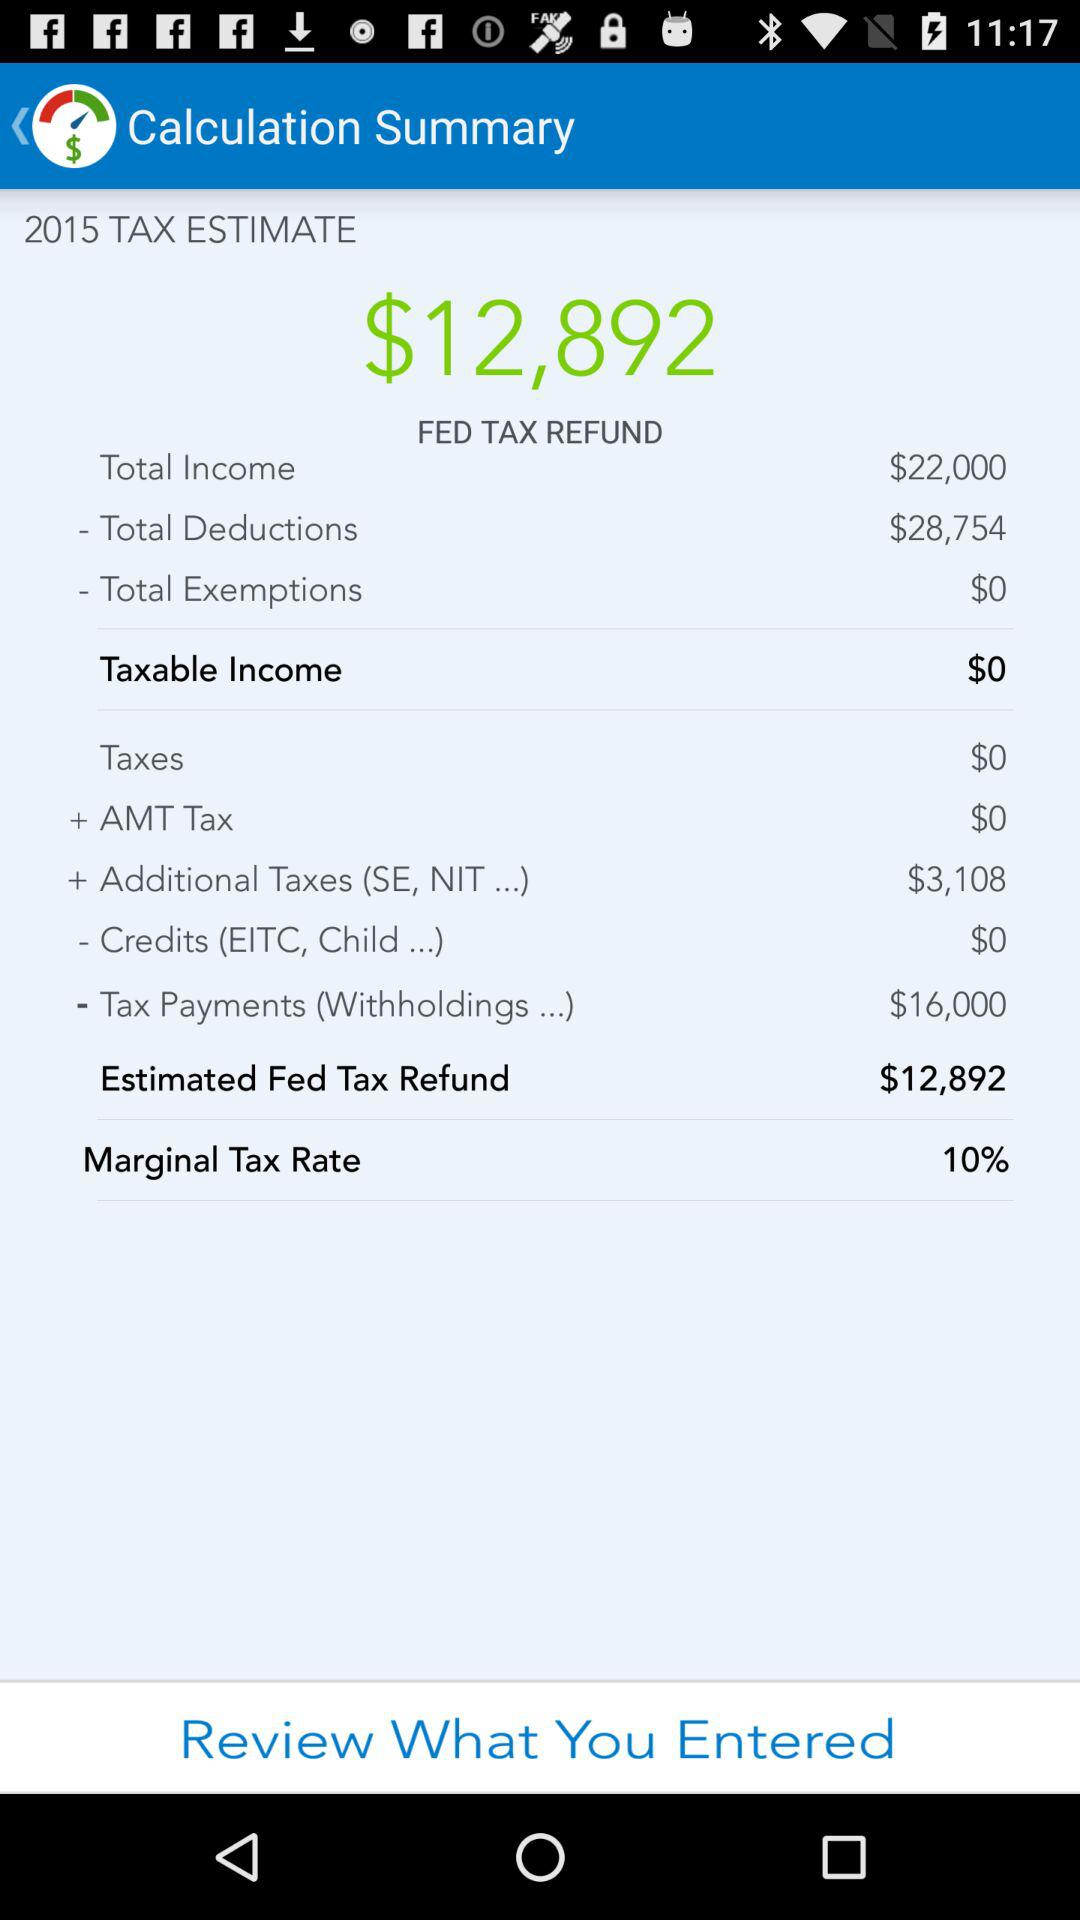What is the total amount of taxes paid?
Answer the question using a single word or phrase. $3,108 